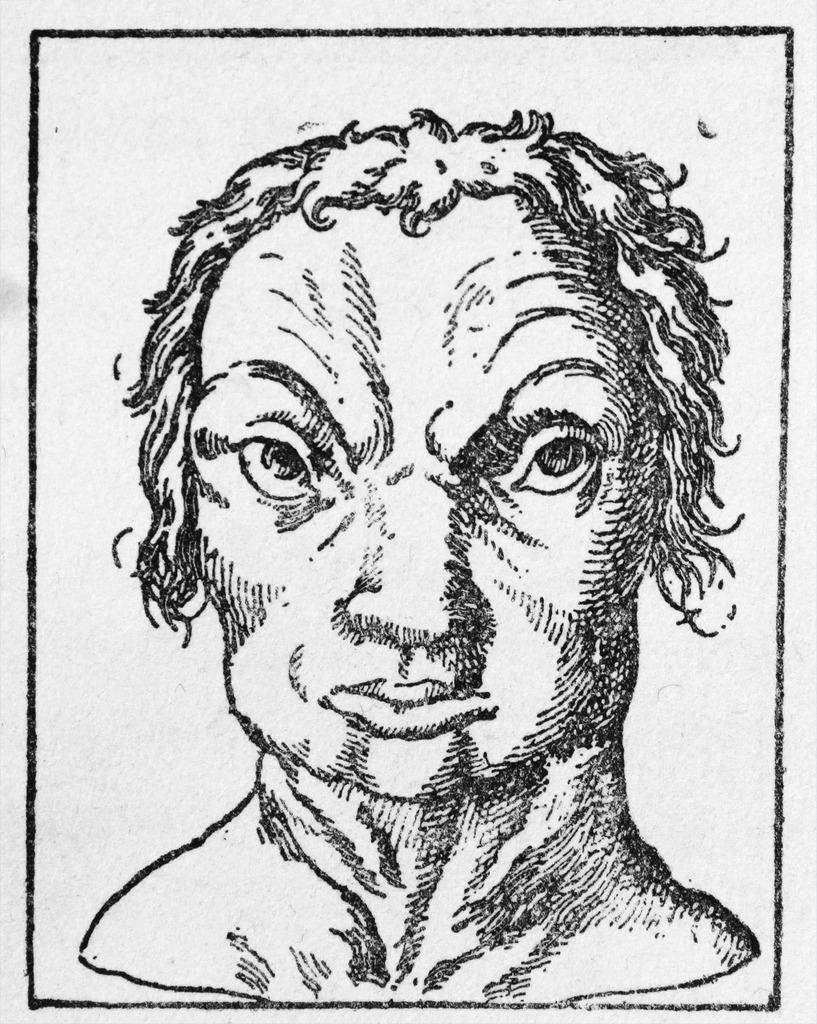Describe this image in one or two sentences. In this image we can see a sketch of a person and the background is white. 